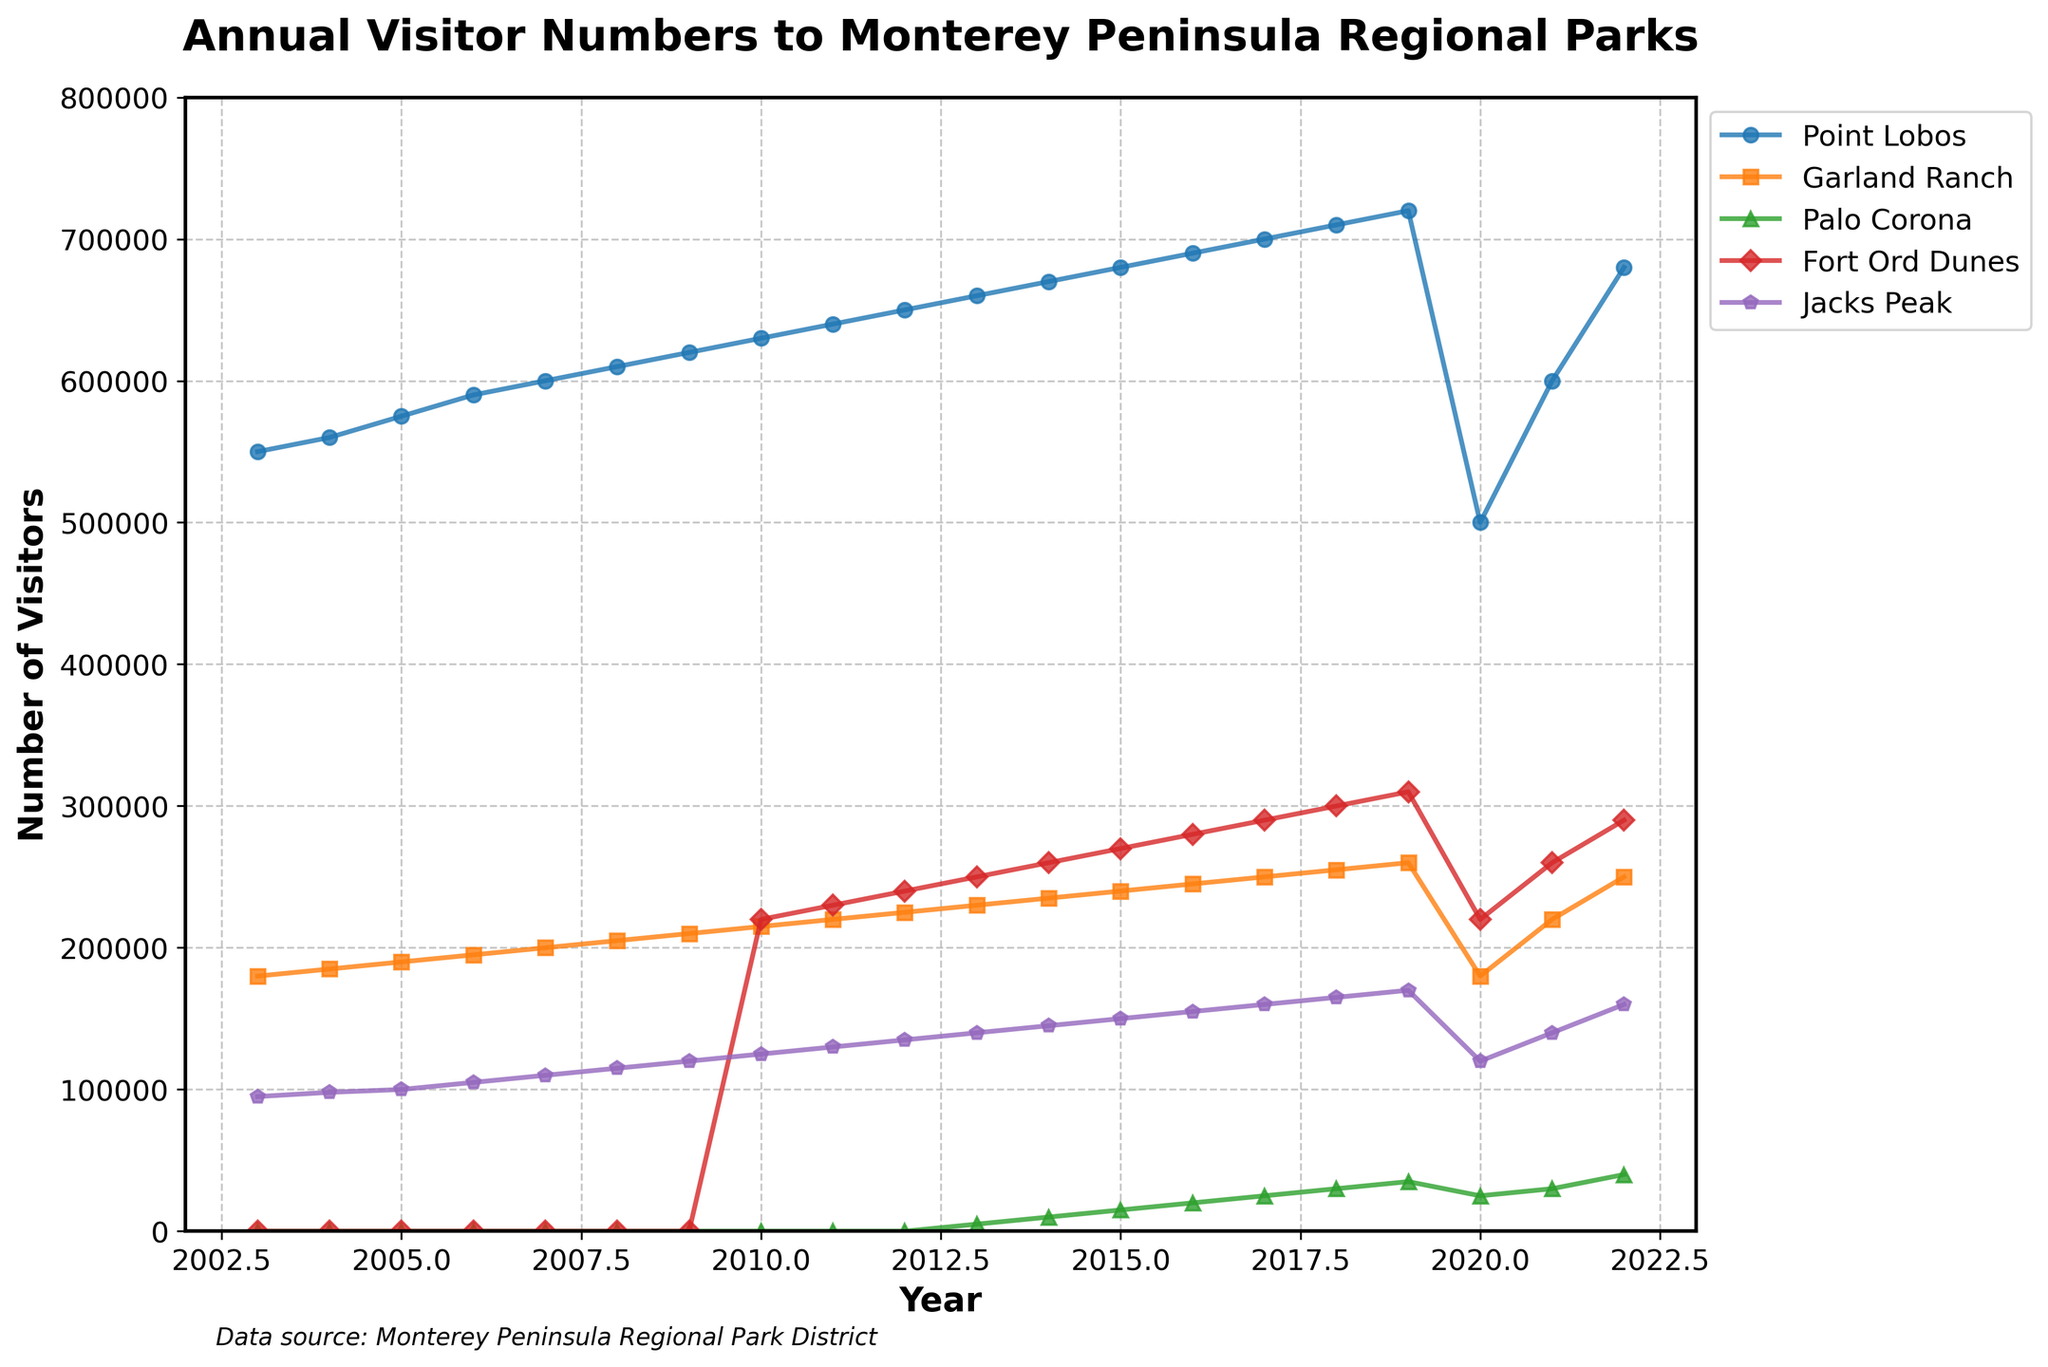What is the overall trend of visitor numbers at Point Lobos over the 20-year period? From 2003 to 2022, the number of visitors to Point Lobos generally increased. The trend shows a steady rise in visitors up to 2019, a significant dip in 2020, and then a recovery in 2021 and 2022.
Answer: Increasing trend Compare the visitor numbers at Palo Corona in 2013 and 2019. In 2013, Palo Corona had 5,000 visitors, whereas in 2019 it had 35,000 visitors. Comparing these two points shows an increase of 30,000 visitors over six years.
Answer: Increase by 30,000 Which park had the steepest increase in visitors between 2010 and 2013? Fort Ord Dunes had the steepest increase, starting from 220,000 visitors in 2010 and reaching 250,000 in 2013, a 30,000 increase over three years. Other parks had smaller changes or no data available during this period.
Answer: Fort Ord Dunes How did the visitor numbers for Jacks Peak change from 2010 to 2022? In 2010, Jacks Peak had 125,000 visitors. By 2022, the number was 160,000. The visitor count increased by 35,000 over these years.
Answer: Increase by 35,000 Which park had the largest drop in visitors in 2020, likely due to the pandemic? Point Lobos had the largest drop, going from 720,000 visitors in 2019 to 500,000 in 2020, a decrease of 220,000.
Answer: Point Lobos What was the difference in visitor numbers between Fort Ord Dunes and Garland Ranch in 2015? Fort Ord Dunes had 270,000 visitors in 2015, while Garland Ranch had 240,000 visitors. The difference is 30,000.
Answer: Difference of 30,000 Identify the year when Palo Corona started receiving visitors and note the initial visitor count. Palo Corona started receiving visitors in 2013 with an initial count of 5,000 visitors.
Answer: 2013, 5,000 visitors Compare the visitor numbers at Fort Ord Dunes and Jacks Peak in 2022. In 2022, Fort Ord Dunes had 290,000 visitors, while Jacks Peak had 160,000 visitors. Fort Ord Dunes had 130,000 more visitors than Jacks Peak.
Answer: Fort Ord Dunes had 130,000 more Which park showed a constant increase in visitor numbers every year from 2003 to 2019? Point Lobos showed a constant increase in visitor numbers from 550,000 in 2003 to 720,000 in 2019. The number increased every single year.
Answer: Point Lobos Calculate the average annual visitors for Garland Ranch from 2003 to 2022. Adding the annual visitors from 2003 (180,000) to 2022 (250,000) gives a total of 5,265,000 over 20 years. The average annual visitors = 5,265,000 / 20 = 263,250.
Answer: 263,250 visitors per year 